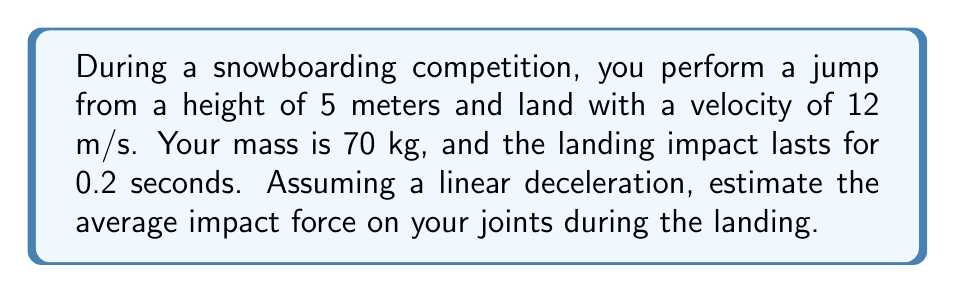Could you help me with this problem? To solve this problem, we'll use the impulse-momentum theorem and Newton's Second Law of Motion. Let's break it down step-by-step:

1. Calculate the change in velocity:
   Initial velocity (at impact): $v_i = 12$ m/s
   Final velocity: $v_f = 0$ m/s
   Change in velocity: $\Delta v = v_f - v_i = 0 - 12 = -12$ m/s

2. Calculate the acceleration:
   $a = \frac{\Delta v}{\Delta t} = \frac{-12}{0.2} = -60$ m/s²

3. Use Newton's Second Law to find the force:
   $F = ma$
   $F = 70 \cdot (-60) = -4200$ N

The negative sign indicates that the force is in the opposite direction of the motion, which is expected for a deceleration.

4. Calculate the magnitude of the force:
   $|F| = 4200$ N

Therefore, the average impact force on your joints during the landing is approximately 4200 N or 4.2 kN.
Answer: 4200 N 